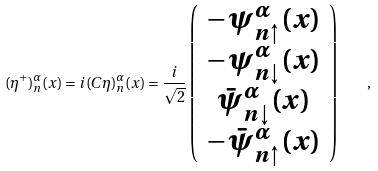Convert formula to latex. <formula><loc_0><loc_0><loc_500><loc_500>( \eta ^ { + } ) _ { n } ^ { \alpha } ( { x } ) = i ( C \eta ) _ { n } ^ { \alpha } ( { x } ) = \frac { i } { \sqrt { 2 } } \left ( \begin{array} { c } - { \psi } _ { n \uparrow } ^ { \alpha } ( { x } ) \\ - { \psi } _ { n \downarrow } ^ { \alpha } ( { x } ) \\ \bar { \psi } _ { n \downarrow } ^ { \alpha } ( { x } ) \\ - \bar { \psi } _ { n \uparrow } ^ { \alpha } ( { x } ) \end{array} \right ) \quad ,</formula> 